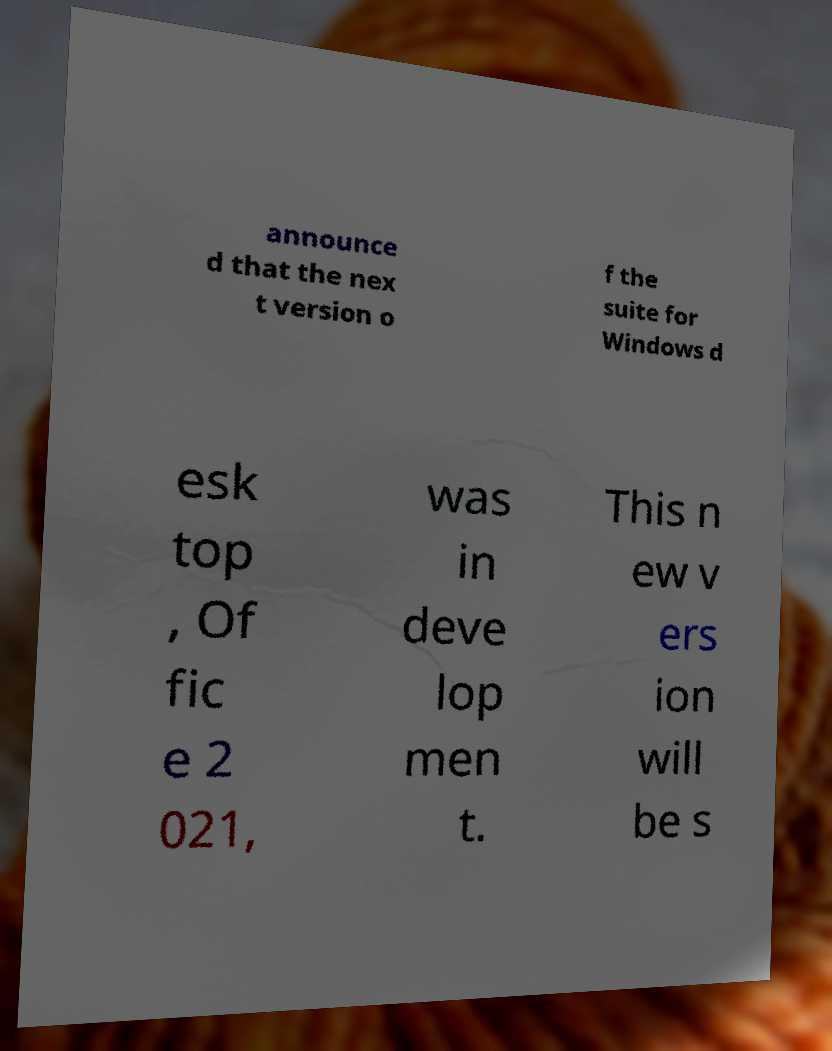Please identify and transcribe the text found in this image. announce d that the nex t version o f the suite for Windows d esk top , Of fic e 2 021, was in deve lop men t. This n ew v ers ion will be s 